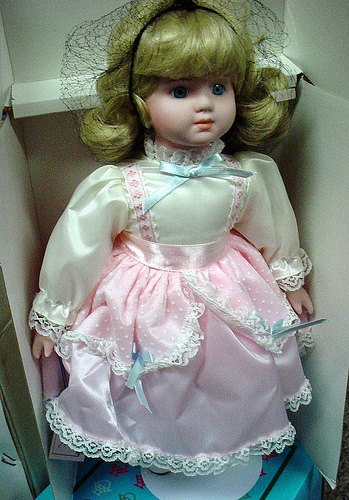<image>
Is the box next to the ribbon? No. The box is not positioned next to the ribbon. They are located in different areas of the scene. 